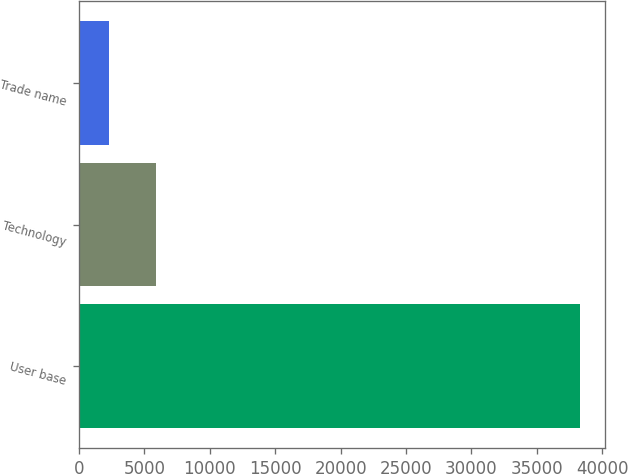<chart> <loc_0><loc_0><loc_500><loc_500><bar_chart><fcel>User base<fcel>Technology<fcel>Trade name<nl><fcel>38300<fcel>5900<fcel>2300<nl></chart> 